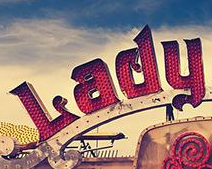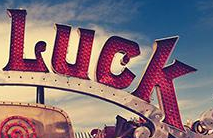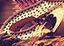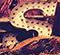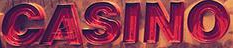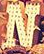What text is displayed in these images sequentially, separated by a semicolon? Lady; Luck; #; S; CASINO; N 